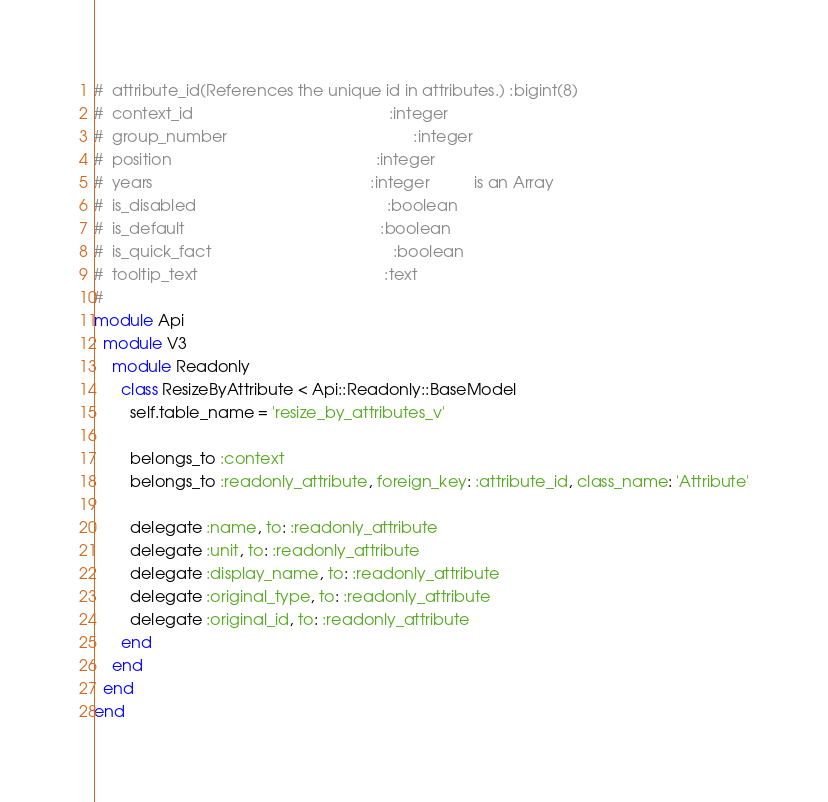Convert code to text. <code><loc_0><loc_0><loc_500><loc_500><_Ruby_>#  attribute_id(References the unique id in attributes.) :bigint(8)
#  context_id                                            :integer
#  group_number                                          :integer
#  position                                              :integer
#  years                                                 :integer          is an Array
#  is_disabled                                           :boolean
#  is_default                                            :boolean
#  is_quick_fact                                         :boolean
#  tooltip_text                                          :text
#
module Api
  module V3
    module Readonly
      class ResizeByAttribute < Api::Readonly::BaseModel
        self.table_name = 'resize_by_attributes_v'

        belongs_to :context
        belongs_to :readonly_attribute, foreign_key: :attribute_id, class_name: 'Attribute'

        delegate :name, to: :readonly_attribute
        delegate :unit, to: :readonly_attribute
        delegate :display_name, to: :readonly_attribute
        delegate :original_type, to: :readonly_attribute
        delegate :original_id, to: :readonly_attribute
      end
    end
  end
end
</code> 